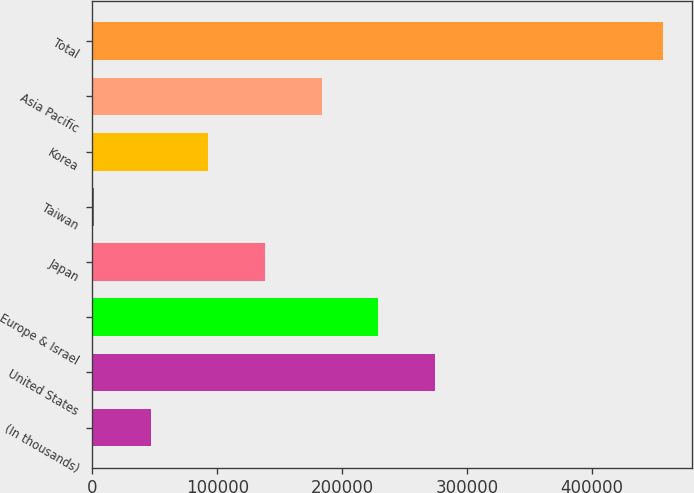Convert chart. <chart><loc_0><loc_0><loc_500><loc_500><bar_chart><fcel>(In thousands)<fcel>United States<fcel>Europe & Israel<fcel>Japan<fcel>Taiwan<fcel>Korea<fcel>Asia Pacific<fcel>Total<nl><fcel>46642.3<fcel>274749<fcel>229128<fcel>137885<fcel>1021<fcel>92263.6<fcel>183506<fcel>457234<nl></chart> 